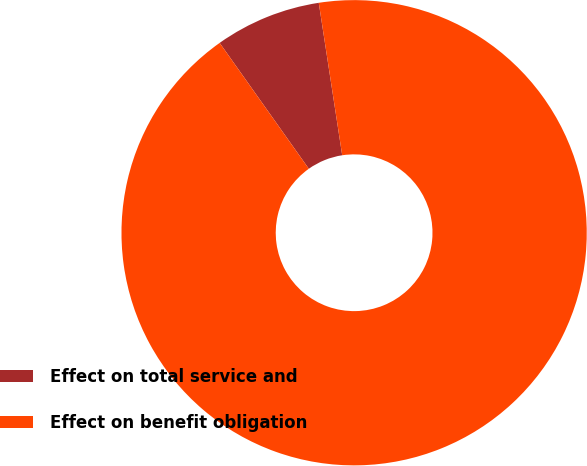<chart> <loc_0><loc_0><loc_500><loc_500><pie_chart><fcel>Effect on total service and<fcel>Effect on benefit obligation<nl><fcel>7.38%<fcel>92.62%<nl></chart> 